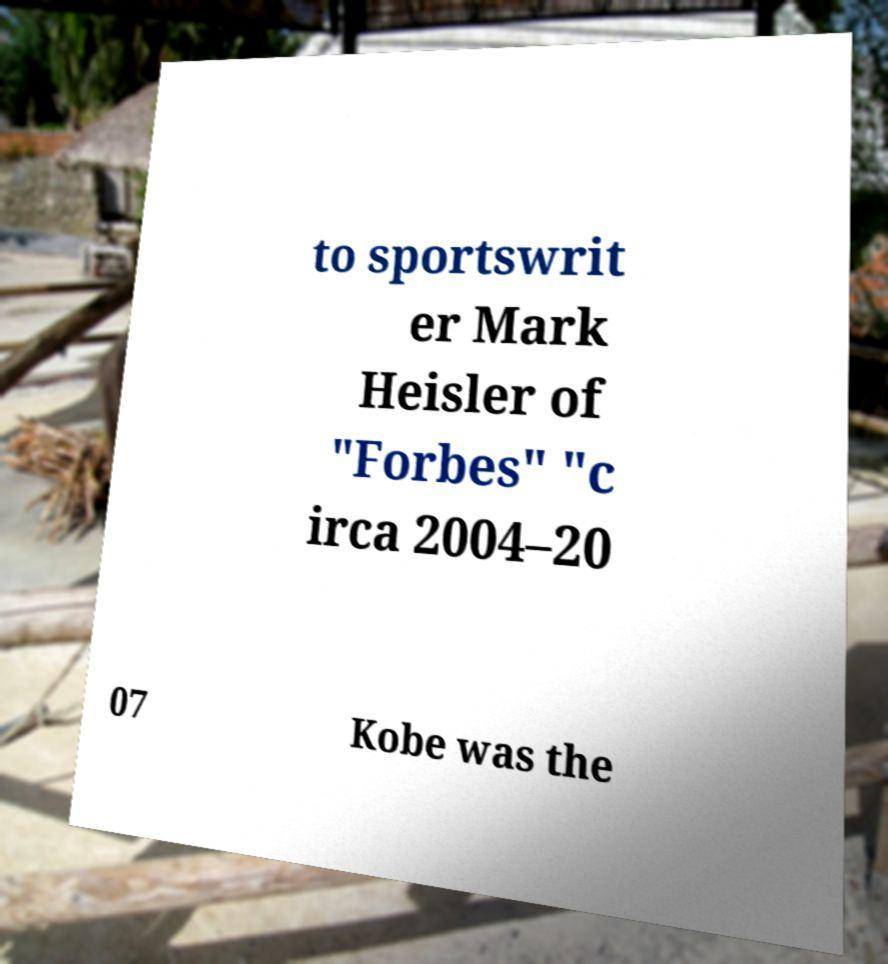Can you accurately transcribe the text from the provided image for me? to sportswrit er Mark Heisler of "Forbes" "c irca 2004–20 07 Kobe was the 